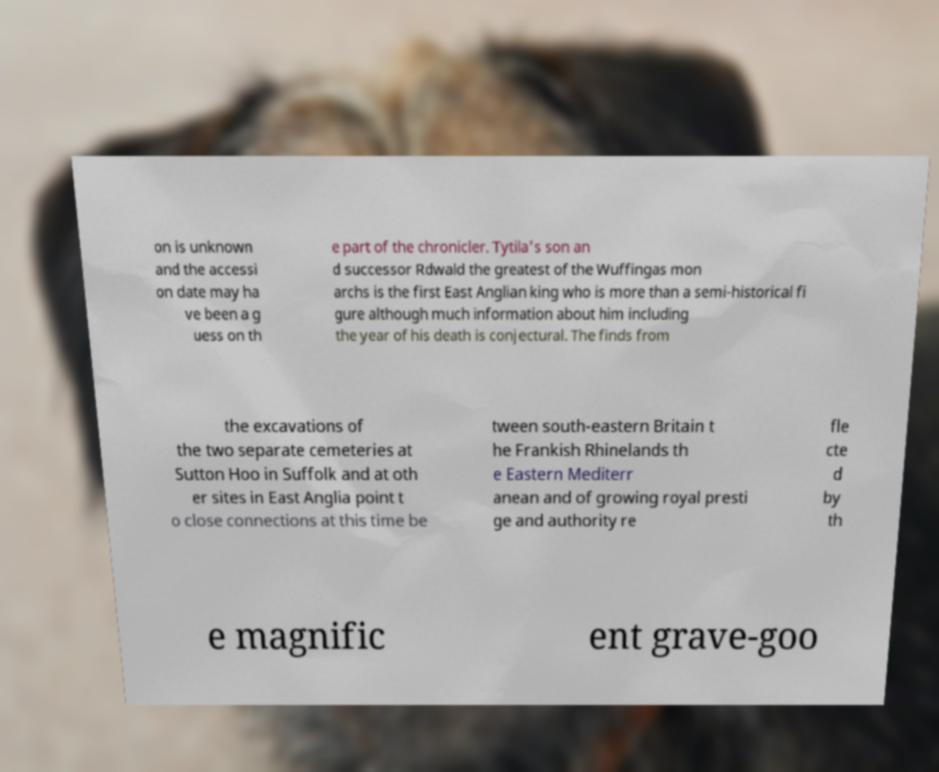I need the written content from this picture converted into text. Can you do that? on is unknown and the accessi on date may ha ve been a g uess on th e part of the chronicler. Tytila's son an d successor Rdwald the greatest of the Wuffingas mon archs is the first East Anglian king who is more than a semi-historical fi gure although much information about him including the year of his death is conjectural. The finds from the excavations of the two separate cemeteries at Sutton Hoo in Suffolk and at oth er sites in East Anglia point t o close connections at this time be tween south-eastern Britain t he Frankish Rhinelands th e Eastern Mediterr anean and of growing royal presti ge and authority re fle cte d by th e magnific ent grave-goo 